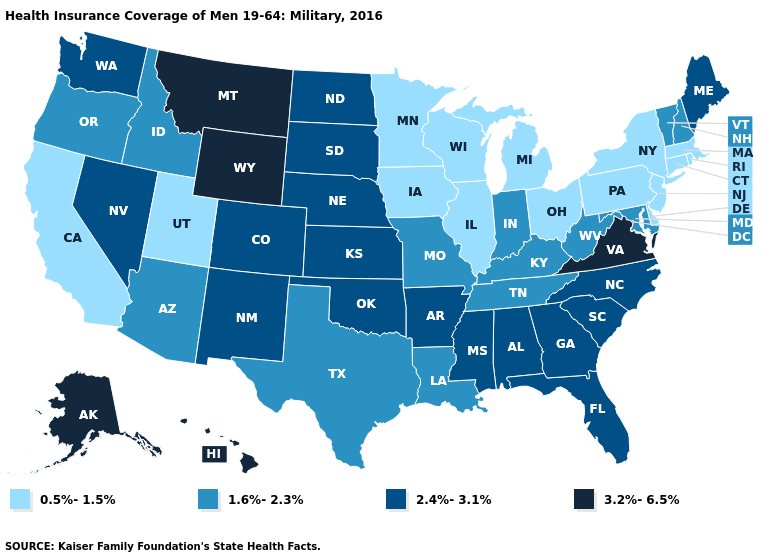Does Delaware have the lowest value in the South?
Quick response, please. Yes. Name the states that have a value in the range 2.4%-3.1%?
Concise answer only. Alabama, Arkansas, Colorado, Florida, Georgia, Kansas, Maine, Mississippi, Nebraska, Nevada, New Mexico, North Carolina, North Dakota, Oklahoma, South Carolina, South Dakota, Washington. Name the states that have a value in the range 3.2%-6.5%?
Give a very brief answer. Alaska, Hawaii, Montana, Virginia, Wyoming. Name the states that have a value in the range 0.5%-1.5%?
Keep it brief. California, Connecticut, Delaware, Illinois, Iowa, Massachusetts, Michigan, Minnesota, New Jersey, New York, Ohio, Pennsylvania, Rhode Island, Utah, Wisconsin. Does Arkansas have the highest value in the USA?
Write a very short answer. No. What is the lowest value in the USA?
Short answer required. 0.5%-1.5%. Which states have the lowest value in the South?
Answer briefly. Delaware. Which states have the lowest value in the USA?
Keep it brief. California, Connecticut, Delaware, Illinois, Iowa, Massachusetts, Michigan, Minnesota, New Jersey, New York, Ohio, Pennsylvania, Rhode Island, Utah, Wisconsin. Among the states that border Arkansas , does Mississippi have the lowest value?
Give a very brief answer. No. What is the highest value in the MidWest ?
Quick response, please. 2.4%-3.1%. Does Oregon have a lower value than Ohio?
Write a very short answer. No. Does Georgia have the same value as South Carolina?
Answer briefly. Yes. Is the legend a continuous bar?
Be succinct. No. Name the states that have a value in the range 0.5%-1.5%?
Write a very short answer. California, Connecticut, Delaware, Illinois, Iowa, Massachusetts, Michigan, Minnesota, New Jersey, New York, Ohio, Pennsylvania, Rhode Island, Utah, Wisconsin. Name the states that have a value in the range 1.6%-2.3%?
Give a very brief answer. Arizona, Idaho, Indiana, Kentucky, Louisiana, Maryland, Missouri, New Hampshire, Oregon, Tennessee, Texas, Vermont, West Virginia. 